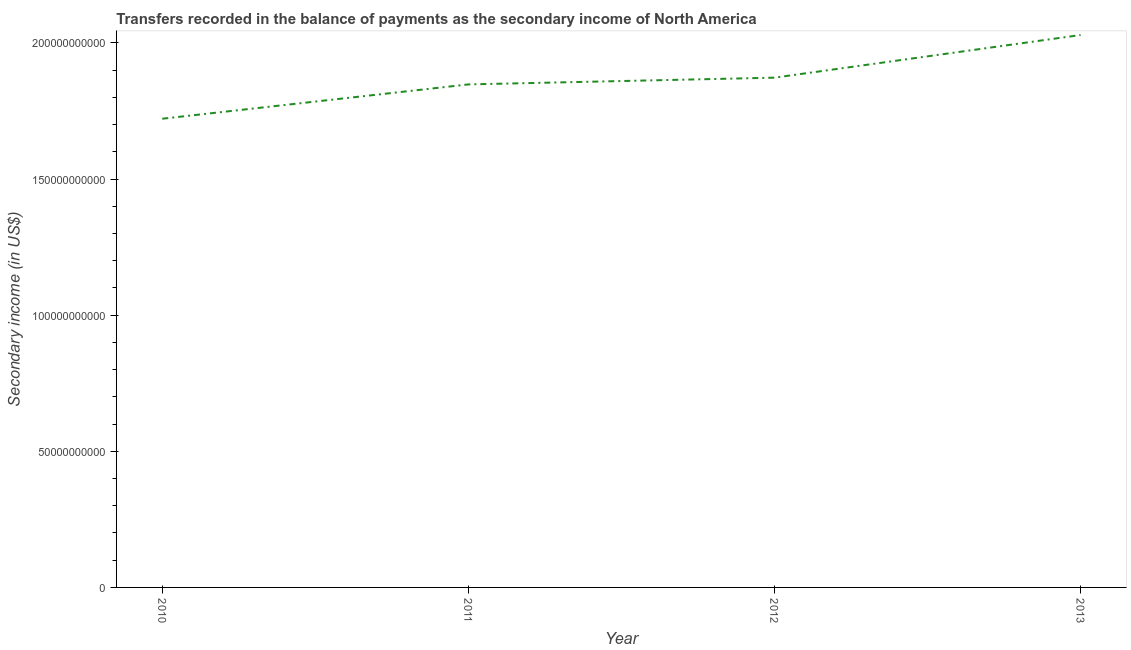What is the amount of secondary income in 2012?
Provide a succinct answer. 1.87e+11. Across all years, what is the maximum amount of secondary income?
Your answer should be compact. 2.03e+11. Across all years, what is the minimum amount of secondary income?
Offer a very short reply. 1.72e+11. In which year was the amount of secondary income maximum?
Provide a short and direct response. 2013. In which year was the amount of secondary income minimum?
Ensure brevity in your answer.  2010. What is the sum of the amount of secondary income?
Offer a terse response. 7.47e+11. What is the difference between the amount of secondary income in 2012 and 2013?
Your answer should be compact. -1.57e+1. What is the average amount of secondary income per year?
Keep it short and to the point. 1.87e+11. What is the median amount of secondary income?
Provide a succinct answer. 1.86e+11. Do a majority of the years between 2013 and 2010 (inclusive) have amount of secondary income greater than 80000000000 US$?
Offer a terse response. Yes. What is the ratio of the amount of secondary income in 2011 to that in 2012?
Provide a short and direct response. 0.99. What is the difference between the highest and the second highest amount of secondary income?
Ensure brevity in your answer.  1.57e+1. What is the difference between the highest and the lowest amount of secondary income?
Give a very brief answer. 3.07e+1. In how many years, is the amount of secondary income greater than the average amount of secondary income taken over all years?
Your answer should be very brief. 2. Does the amount of secondary income monotonically increase over the years?
Provide a succinct answer. Yes. How many lines are there?
Your answer should be very brief. 1. How many years are there in the graph?
Ensure brevity in your answer.  4. Are the values on the major ticks of Y-axis written in scientific E-notation?
Keep it short and to the point. No. Does the graph contain any zero values?
Your response must be concise. No. What is the title of the graph?
Ensure brevity in your answer.  Transfers recorded in the balance of payments as the secondary income of North America. What is the label or title of the X-axis?
Your response must be concise. Year. What is the label or title of the Y-axis?
Give a very brief answer. Secondary income (in US$). What is the Secondary income (in US$) of 2010?
Make the answer very short. 1.72e+11. What is the Secondary income (in US$) of 2011?
Offer a very short reply. 1.85e+11. What is the Secondary income (in US$) in 2012?
Ensure brevity in your answer.  1.87e+11. What is the Secondary income (in US$) of 2013?
Offer a terse response. 2.03e+11. What is the difference between the Secondary income (in US$) in 2010 and 2011?
Ensure brevity in your answer.  -1.26e+1. What is the difference between the Secondary income (in US$) in 2010 and 2012?
Your answer should be compact. -1.51e+1. What is the difference between the Secondary income (in US$) in 2010 and 2013?
Your answer should be very brief. -3.07e+1. What is the difference between the Secondary income (in US$) in 2011 and 2012?
Your response must be concise. -2.48e+09. What is the difference between the Secondary income (in US$) in 2011 and 2013?
Your answer should be compact. -1.81e+1. What is the difference between the Secondary income (in US$) in 2012 and 2013?
Your answer should be compact. -1.57e+1. What is the ratio of the Secondary income (in US$) in 2010 to that in 2011?
Offer a very short reply. 0.93. What is the ratio of the Secondary income (in US$) in 2010 to that in 2012?
Your answer should be compact. 0.92. What is the ratio of the Secondary income (in US$) in 2010 to that in 2013?
Give a very brief answer. 0.85. What is the ratio of the Secondary income (in US$) in 2011 to that in 2012?
Give a very brief answer. 0.99. What is the ratio of the Secondary income (in US$) in 2011 to that in 2013?
Make the answer very short. 0.91. What is the ratio of the Secondary income (in US$) in 2012 to that in 2013?
Keep it short and to the point. 0.92. 